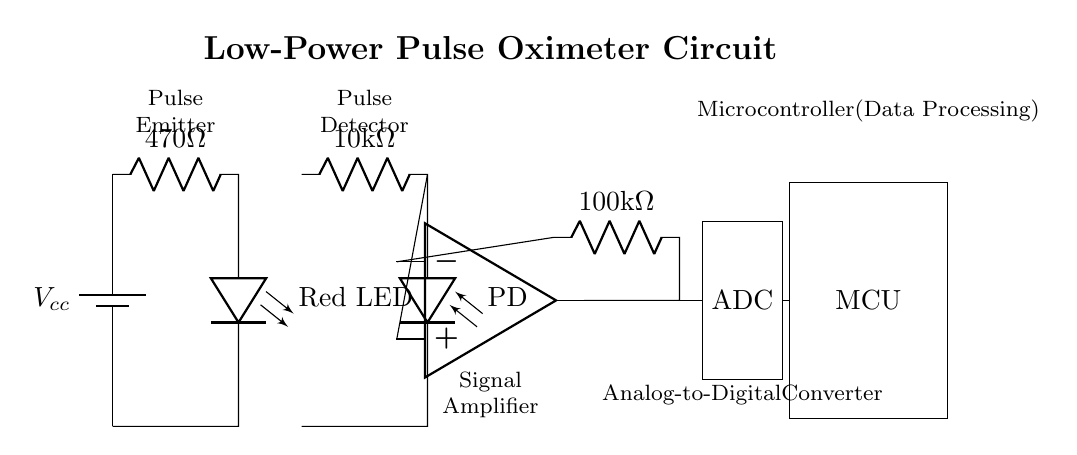What power supply is used for the circuit? The circuit uses a battery as indicated by the 'battery1' symbol connected at the top left. The label shows it is designated as Vcc.
Answer: Vcc What is the resistance of the LED resistor? The diagram shows a resistor labeled with a value of 470 Ohms connected in series with the LED. This value is critical for limiting current through the LED.
Answer: 470 Ohm How many components are in series with the LED? The series arrangement includes just two components: the LED and the LED resistor. This can be seen clearly in the path from the battery through the resistor to the LED.
Answer: 2 components What is the purpose of the photodiode in this circuit? The photodiode functions to detect the light emitted by the LED, which is essential for measuring the blood oxygen levels by detecting absorption changes.
Answer: Light detection How does the signal get from the photodiode to the microcontroller? The signal flows from the photodiode through the resistor to the operational amplifier, which amplifies the signal before it is sent to the analog-to-digital converter, and finally to the microcontroller for processing. The path is sequential flowing from one component to the next.
Answer: Through the operational amplifier and ADC What is the gain setting resistor value connected to the operational amplifier? The resistor connected to the operational amplifier is labeled with a value of 100k Ohms, which determines the gain of the amplifier in the circuit.
Answer: 100k Ohm What are the components involved in processing the digital signal? The digital signal processing involves the Analog-to-Digital Converter (ADC) and the Microcontroller (MCU), both of which are critical for interpreting the signal linearly into meaningful data concerning blood oxygen levels.
Answer: ADC and MCU 